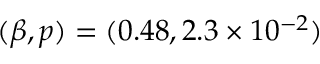Convert formula to latex. <formula><loc_0><loc_0><loc_500><loc_500>( \beta , p ) = ( 0 . 4 8 , 2 . 3 \times 1 0 ^ { - 2 } )</formula> 